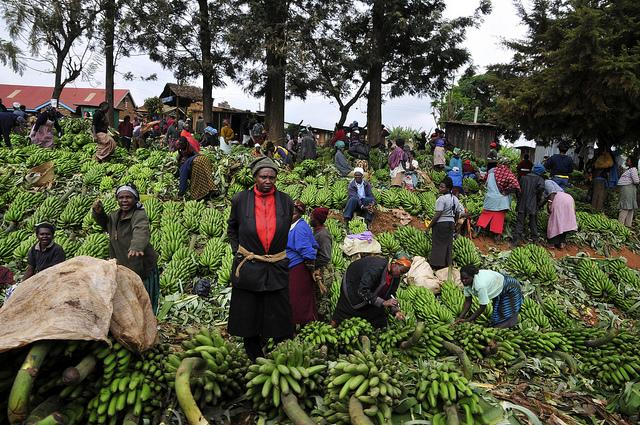What food group do these plantains belong to? Please explain your reasoning. fruits. I chose the food group that bananas belong to. 